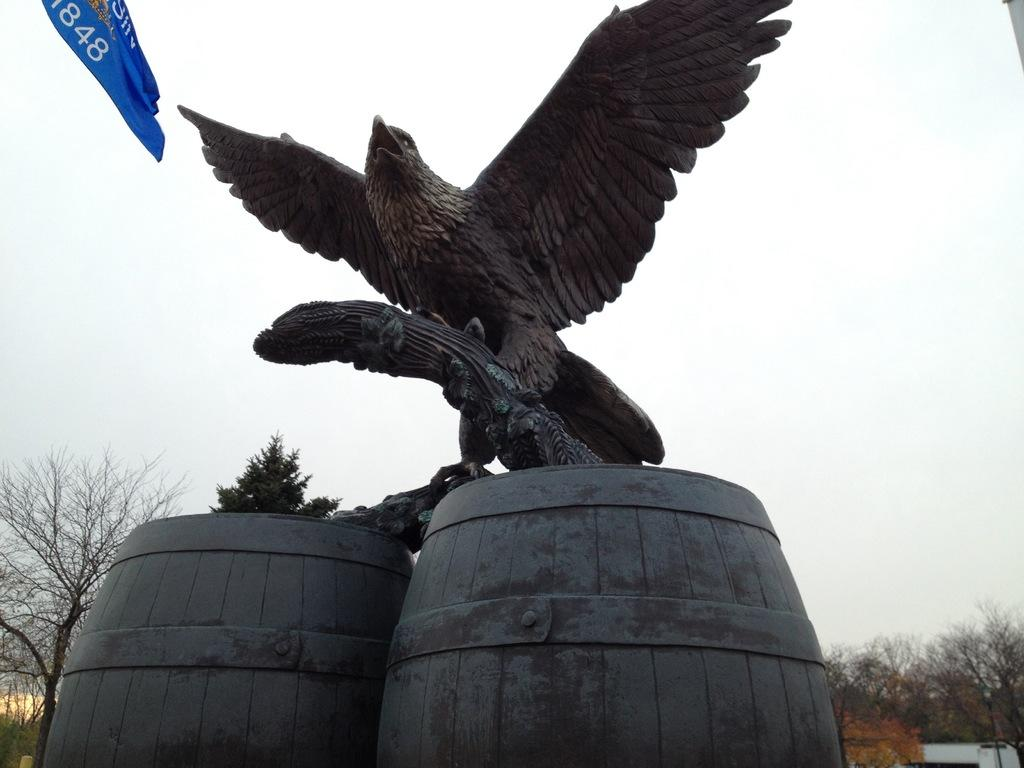What is the main subject in the center of the image? There is a sculpture in the center of the image. What objects are located at the bottom of the image? There are barrels at the bottom of the image. What can be seen in the background of the image? There are trees and sky visible in the background of the image. Where is the flag positioned in the image? The flag is on the left side of the image. What color is the lettuce in the image? There is no lettuce present in the image. 